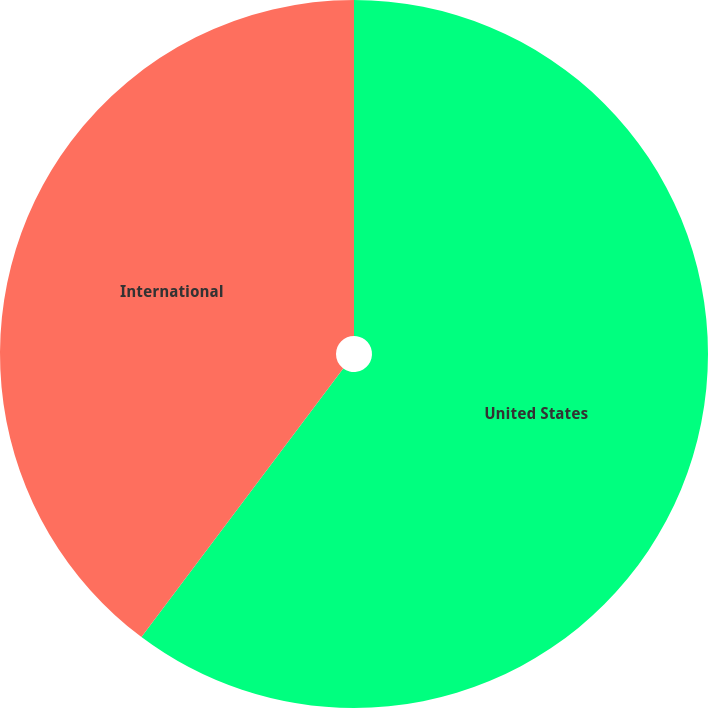Convert chart. <chart><loc_0><loc_0><loc_500><loc_500><pie_chart><fcel>United States<fcel>International<nl><fcel>60.25%<fcel>39.75%<nl></chart> 